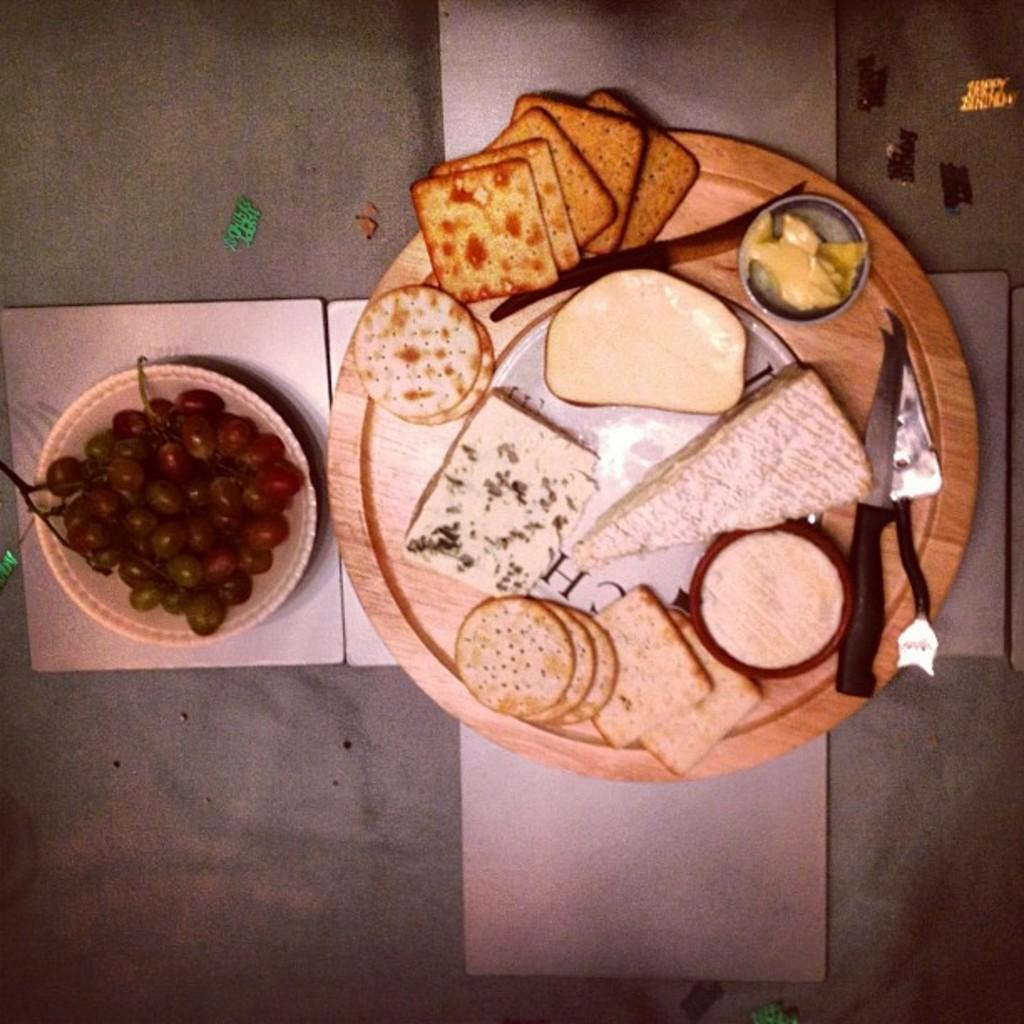What is on the plate that is visible in the image? There is a plate with food items in the image. What utensil is present on the plate? A knife is present on the plate. What type of fruit can be seen in the bowl in the image? There is a bowl with grapes in the image. What is the surface on which all these items are placed? All of these items are placed on a platform. What type of shock can be seen on the father's face in the image? There is no father or any indication of shock present in the image. 